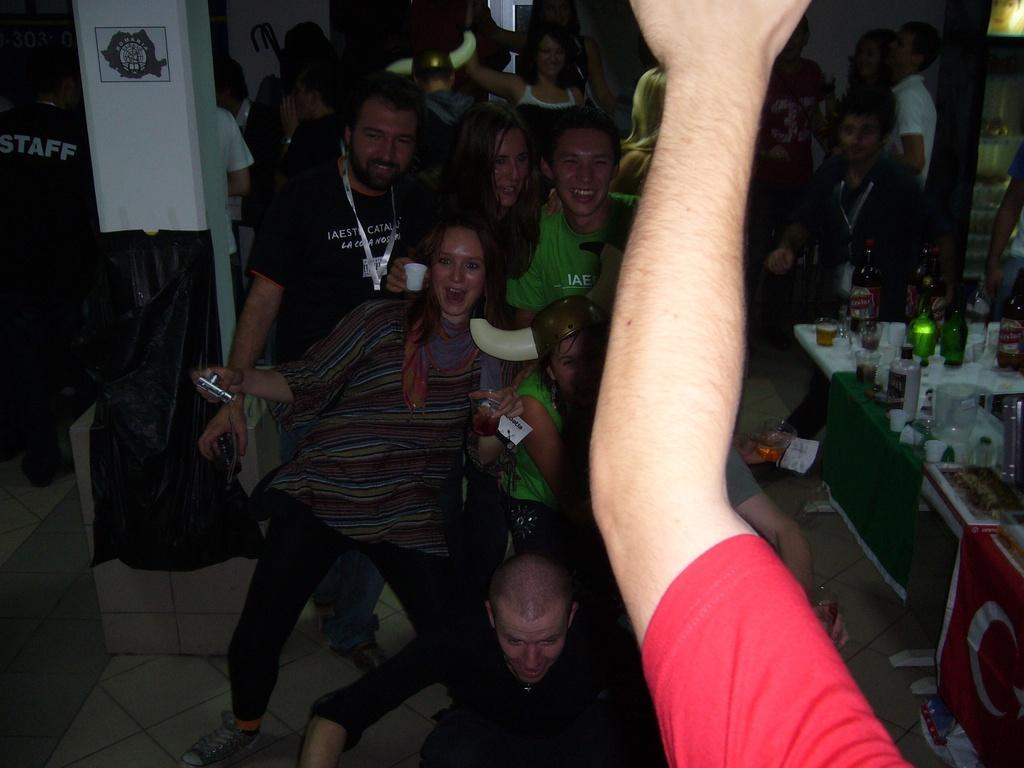In one or two sentences, can you explain what this image depicts? In the image we can see there are many people standing and sitting. They are wearing clothes and some of them are laughing. Here we can see bottles, pillar, poster and the floor. Here we can see a woman smiling and holding an object in hand. 